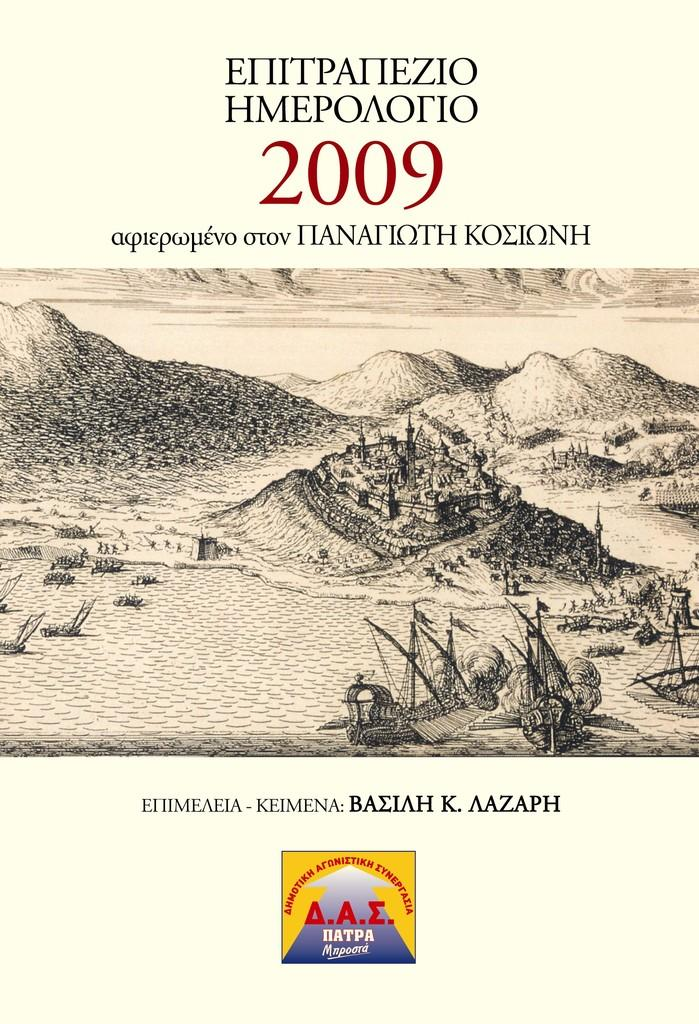<image>
Share a concise interpretation of the image provided. A book with Russian writing on it also displays the year 2009. 